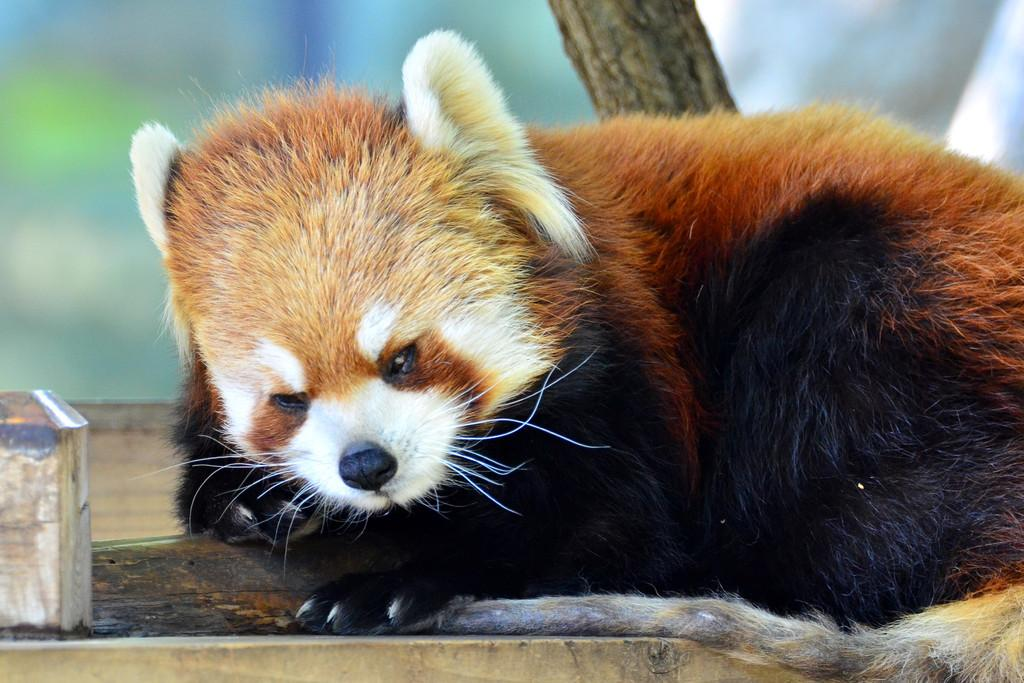What is the main subject in the front of the image? There is an animal in the front of the image. What can be seen in the center of the image? There is a tree trunk in the center of the image. How would you describe the background of the image? The background of the image is blurry. What month is the fairy festival taking place in the image? There are no fairies or festivals present in the image; it features an animal and a tree trunk. 